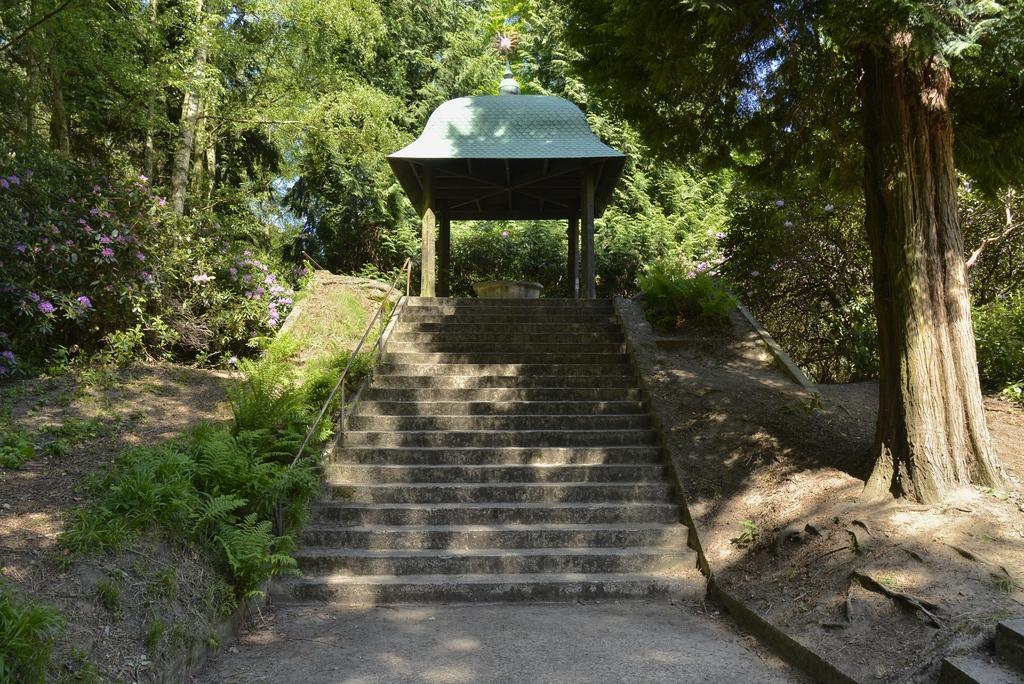Can you describe this image briefly? In this image we can see the stairs, plants, pergola and the trees in the background. 